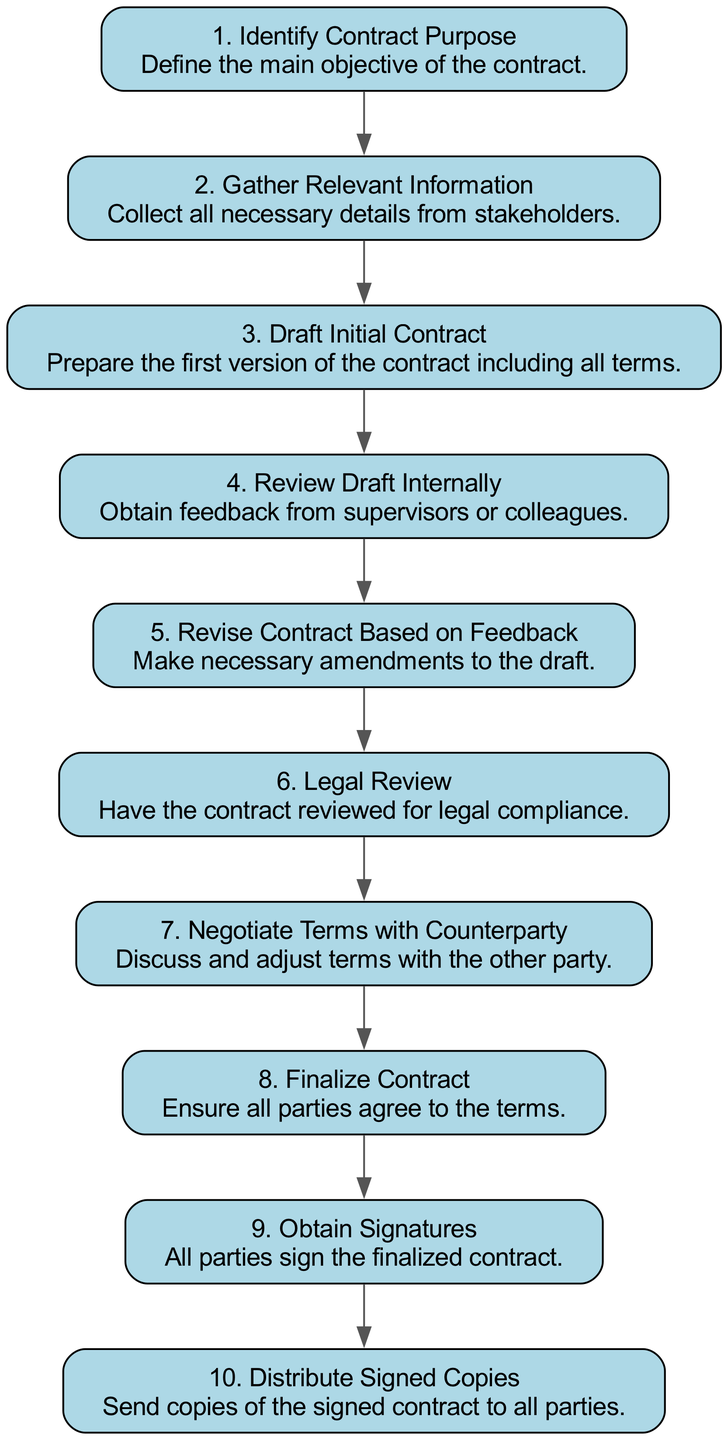What is the first step in the contract drafting process? The diagram shows the first node titled "Identify Contract Purpose" as step 1, which outlines the main objective of the contract. Since it's the first entry in the flow, it marks the commencement of the contract drafting process.
Answer: Identify Contract Purpose How many steps are there in total to draft a contract? By counting the steps listed in the diagram, there are a total of 10 distinct steps from the identification of the contract purpose to the distribution of signed copies.
Answer: 10 Which step involves collecting information from stakeholders? The diagram indicates that in step 2, titled "Gather Relevant Information," is dedicated to collecting necessary details from stakeholders to facilitate the drafting process.
Answer: Gather Relevant Information What is the relationship between "Review Draft Internally" and "Revise Contract Based on Feedback"? The diagram illustrates that "Review Draft Internally" (step 4) leads directly to "Revise Contract Based on Feedback" (step 5), indicating that internal reviews prompt revisions based on the feedback received.
Answer: Feedback prompts revisions What is the last step of the contract drafting process? According to the diagram, the last step is "Distribute Signed Copies," which is labeled as step 10, demonstrating that once all parties have signed, the finalized contract copies are distributed.
Answer: Distribute Signed Copies Which step comes directly after "Negotiate Terms with Counterparty"? The flow chart shows that after "Negotiate Terms with Counterparty" (step 7), the next step is "Finalize Contract" (step 8), indicating that negotiations culminate in finalizing the contract.
Answer: Finalize Contract What does the step "Legal Review" ensure? The step labeled "Legal Review" (step 6) is meant to ensure that the contract complies with legal requirements, as stated in the description of that node, highlighting its importance for legal adherence.
Answer: Legal compliance How many nodes are there in the flow chart that pertain to review processes? Counting the nodes, there are two steps specifically related to review: "Review Draft Internally" (step 4) and "Legal Review" (step 6), totaling to two review-related nodes in the contract drafting flow chart.
Answer: 2 What action follows after obtaining signatures? The next action after "Obtain Signatures" (step 9) is "Distribute Signed Copies" (step 10), demonstrating that after signatures are collected, the signed copies are distributed to all parties involved.
Answer: Distribute Signed Copies 